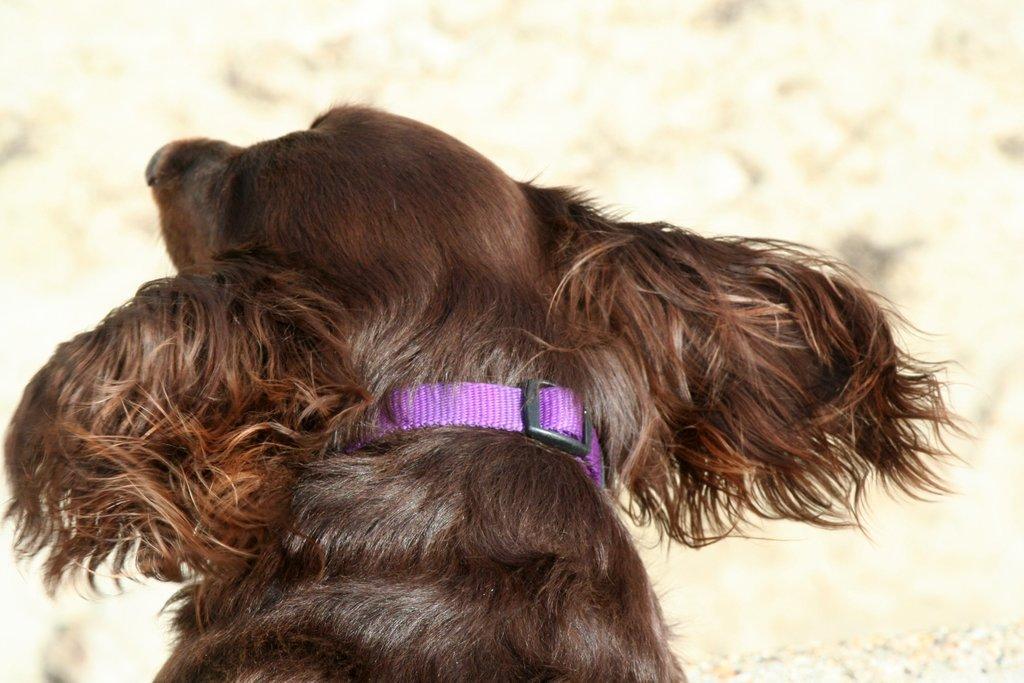How would you summarize this image in a sentence or two? In this image there is a dog in the foreground, background is blurry. 